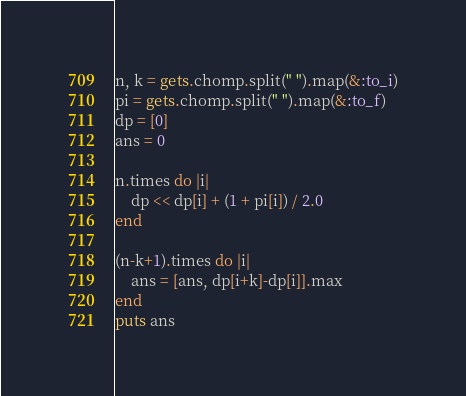<code> <loc_0><loc_0><loc_500><loc_500><_Ruby_>n, k = gets.chomp.split(" ").map(&:to_i)
pi = gets.chomp.split(" ").map(&:to_f)
dp = [0]
ans = 0

n.times do |i|
    dp << dp[i] + (1 + pi[i]) / 2.0
end

(n-k+1).times do |i|
    ans = [ans, dp[i+k]-dp[i]].max
end
puts ans</code> 